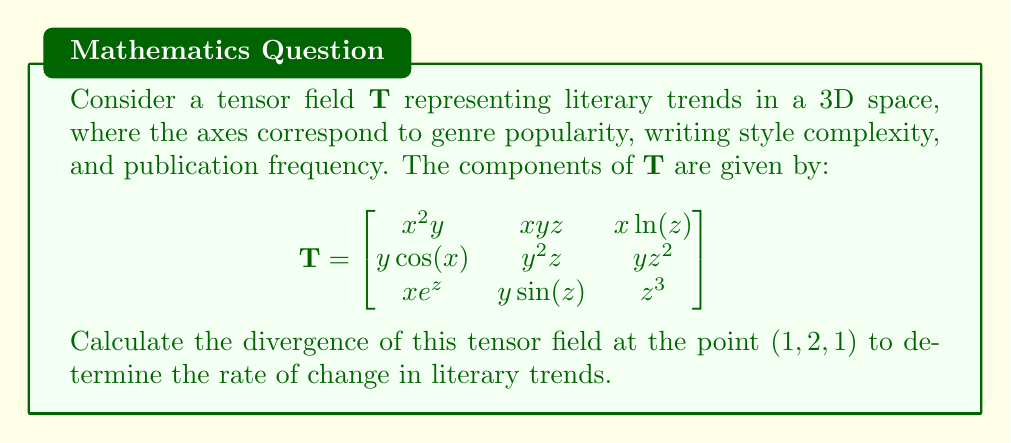Provide a solution to this math problem. To find the divergence of the tensor field $\mathbf{T}$, we need to calculate the sum of the partial derivatives of the diagonal elements with respect to their corresponding variables. The divergence is given by:

$$\text{div}(\mathbf{T}) = \frac{\partial T_{xx}}{\partial x} + \frac{\partial T_{yy}}{\partial y} + \frac{\partial T_{zz}}{\partial z}$$

Let's calculate each term:

1. $\frac{\partial T_{xx}}{\partial x}$:
   $T_{xx} = x^2y$
   $\frac{\partial T_{xx}}{\partial x} = 2xy$
   At $(1, 2, 1)$: $2(1)(2) = 4$

2. $\frac{\partial T_{yy}}{\partial y}$:
   $T_{yy} = y^2z$
   $\frac{\partial T_{yy}}{\partial y} = 2yz$
   At $(1, 2, 1)$: $2(2)(1) = 4$

3. $\frac{\partial T_{zz}}{\partial z}$:
   $T_{zz} = z^3$
   $\frac{\partial T_{zz}}{\partial z} = 3z^2$
   At $(1, 2, 1)$: $3(1)^2 = 3$

Now, we sum these partial derivatives:

$$\text{div}(\mathbf{T}) = 4 + 4 + 3 = 11$$

This value represents the rate of change in literary trends at the point $(1, 2, 1)$ in our 3D space of genre popularity, writing style complexity, and publication frequency.
Answer: 11 